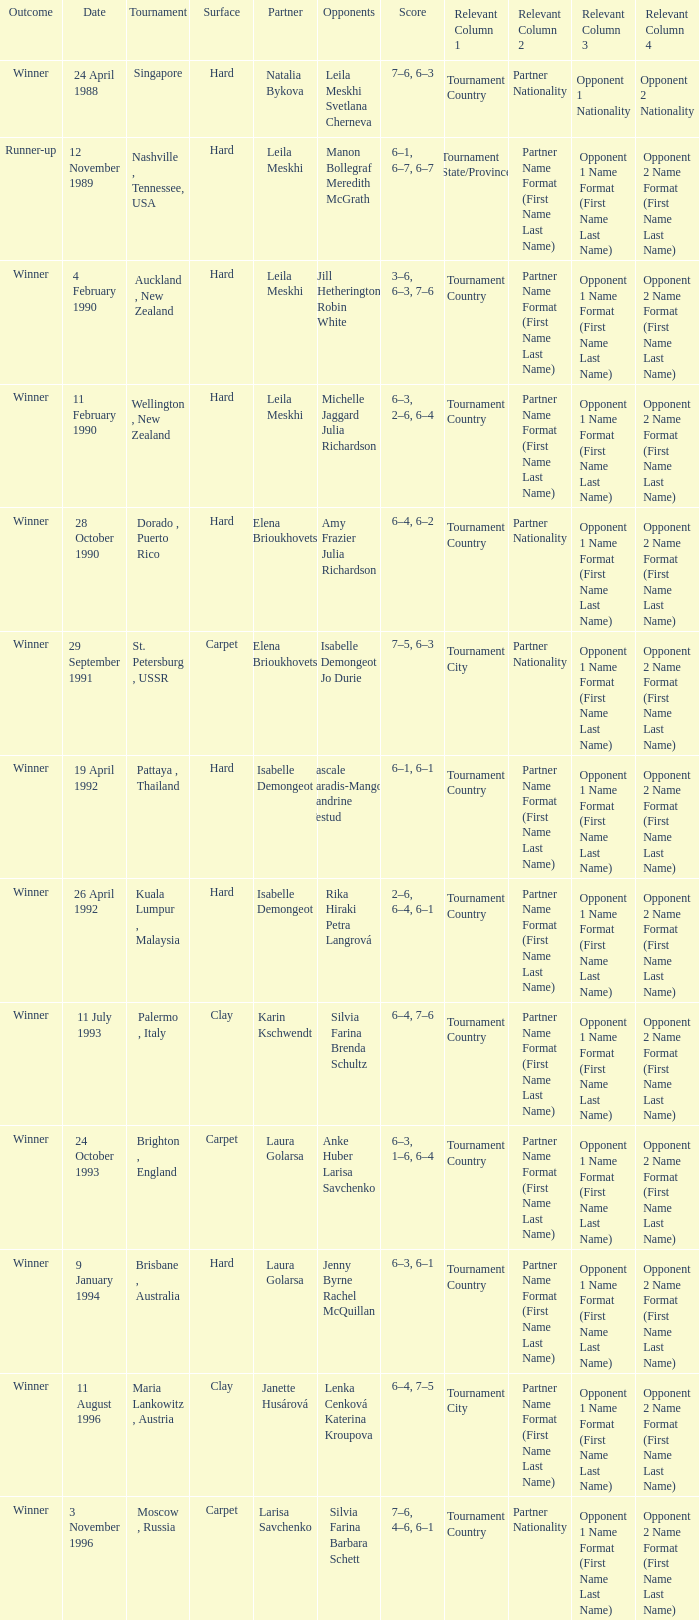When was the score recorded as 6-4, 6-2? 28 October 1990. 